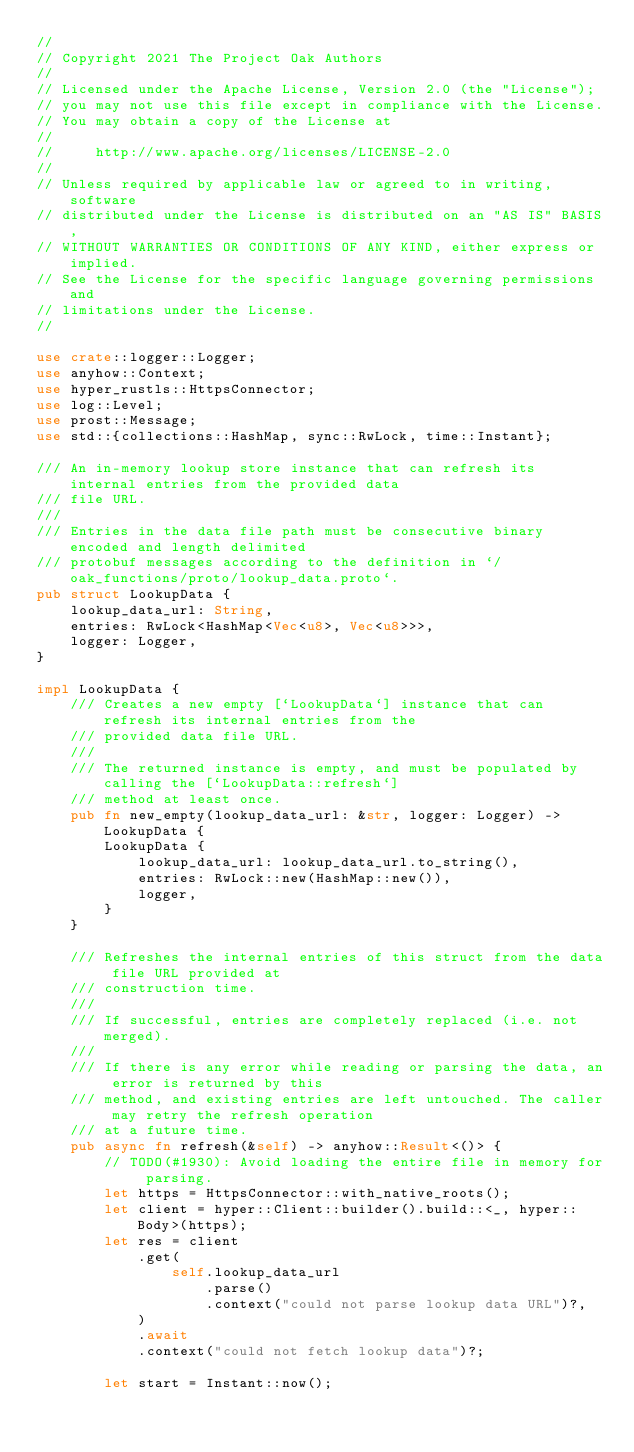Convert code to text. <code><loc_0><loc_0><loc_500><loc_500><_Rust_>//
// Copyright 2021 The Project Oak Authors
//
// Licensed under the Apache License, Version 2.0 (the "License");
// you may not use this file except in compliance with the License.
// You may obtain a copy of the License at
//
//     http://www.apache.org/licenses/LICENSE-2.0
//
// Unless required by applicable law or agreed to in writing, software
// distributed under the License is distributed on an "AS IS" BASIS,
// WITHOUT WARRANTIES OR CONDITIONS OF ANY KIND, either express or implied.
// See the License for the specific language governing permissions and
// limitations under the License.
//

use crate::logger::Logger;
use anyhow::Context;
use hyper_rustls::HttpsConnector;
use log::Level;
use prost::Message;
use std::{collections::HashMap, sync::RwLock, time::Instant};

/// An in-memory lookup store instance that can refresh its internal entries from the provided data
/// file URL.
///
/// Entries in the data file path must be consecutive binary encoded and length delimited
/// protobuf messages according to the definition in `/oak_functions/proto/lookup_data.proto`.
pub struct LookupData {
    lookup_data_url: String,
    entries: RwLock<HashMap<Vec<u8>, Vec<u8>>>,
    logger: Logger,
}

impl LookupData {
    /// Creates a new empty [`LookupData`] instance that can refresh its internal entries from the
    /// provided data file URL.
    ///
    /// The returned instance is empty, and must be populated by calling the [`LookupData::refresh`]
    /// method at least once.
    pub fn new_empty(lookup_data_url: &str, logger: Logger) -> LookupData {
        LookupData {
            lookup_data_url: lookup_data_url.to_string(),
            entries: RwLock::new(HashMap::new()),
            logger,
        }
    }

    /// Refreshes the internal entries of this struct from the data file URL provided at
    /// construction time.
    ///
    /// If successful, entries are completely replaced (i.e. not merged).
    ///
    /// If there is any error while reading or parsing the data, an error is returned by this
    /// method, and existing entries are left untouched. The caller may retry the refresh operation
    /// at a future time.
    pub async fn refresh(&self) -> anyhow::Result<()> {
        // TODO(#1930): Avoid loading the entire file in memory for parsing.
        let https = HttpsConnector::with_native_roots();
        let client = hyper::Client::builder().build::<_, hyper::Body>(https);
        let res = client
            .get(
                self.lookup_data_url
                    .parse()
                    .context("could not parse lookup data URL")?,
            )
            .await
            .context("could not fetch lookup data")?;

        let start = Instant::now();</code> 